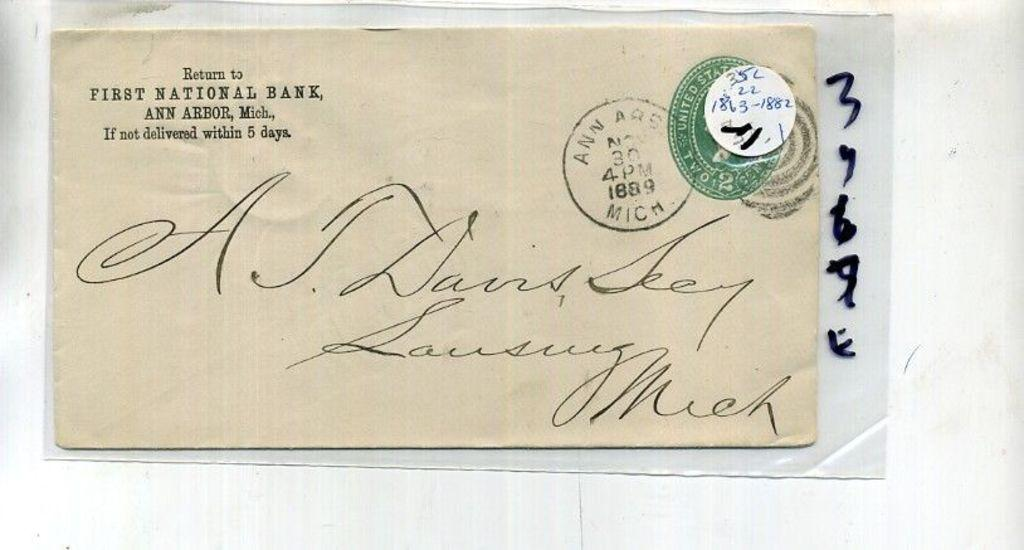<image>
Relay a brief, clear account of the picture shown. An envelope with a return address they says First National Bank and is addressed to A.J. Dains Seey. 